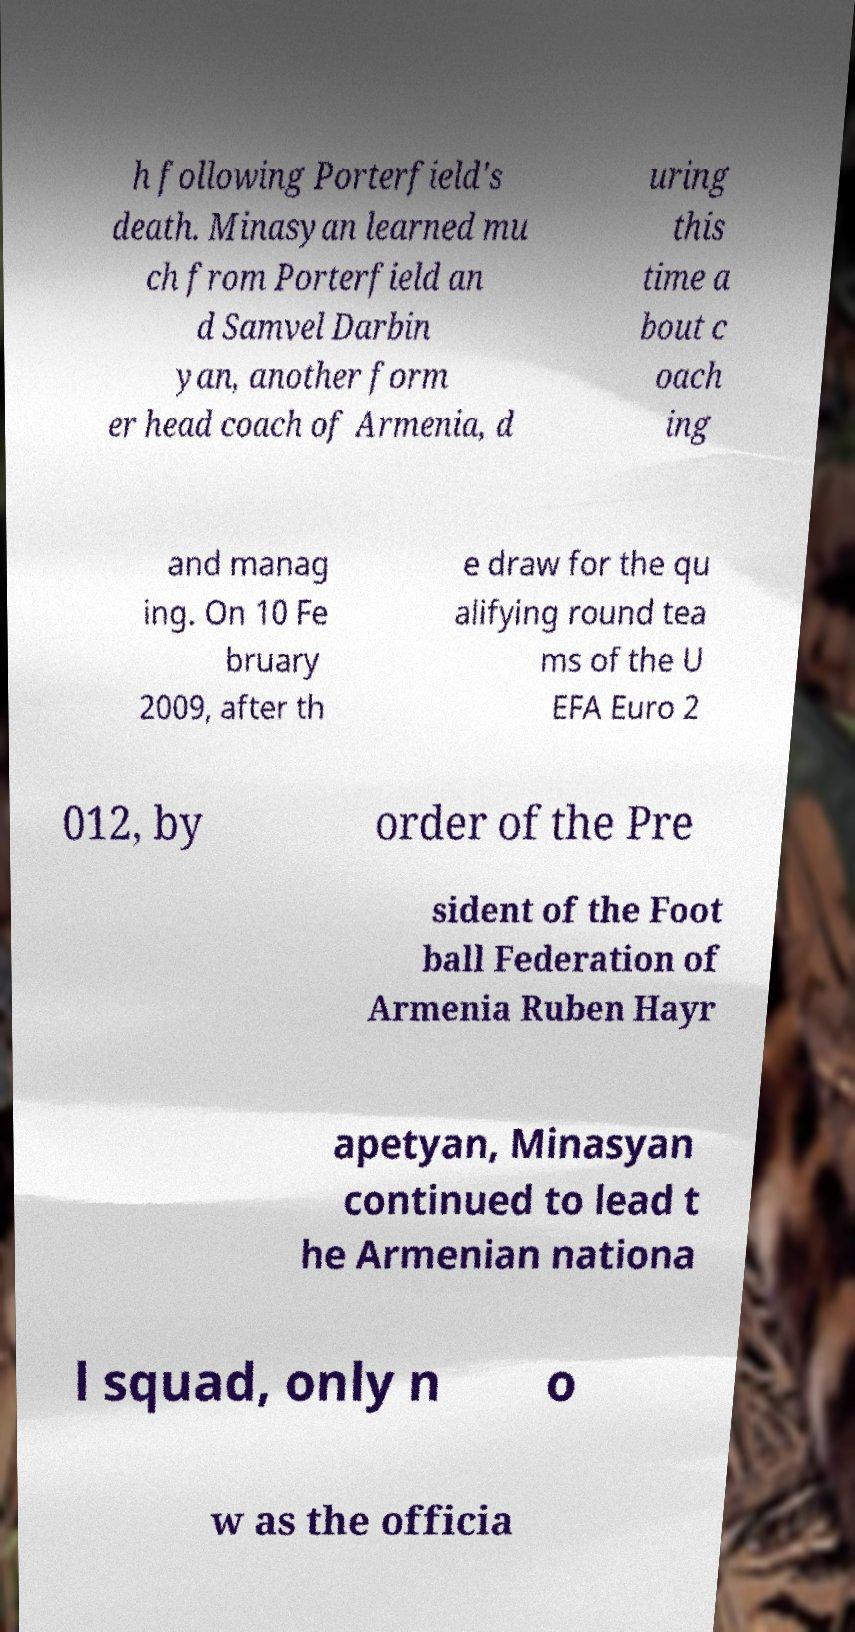Could you assist in decoding the text presented in this image and type it out clearly? h following Porterfield's death. Minasyan learned mu ch from Porterfield an d Samvel Darbin yan, another form er head coach of Armenia, d uring this time a bout c oach ing and manag ing. On 10 Fe bruary 2009, after th e draw for the qu alifying round tea ms of the U EFA Euro 2 012, by order of the Pre sident of the Foot ball Federation of Armenia Ruben Hayr apetyan, Minasyan continued to lead t he Armenian nationa l squad, only n o w as the officia 